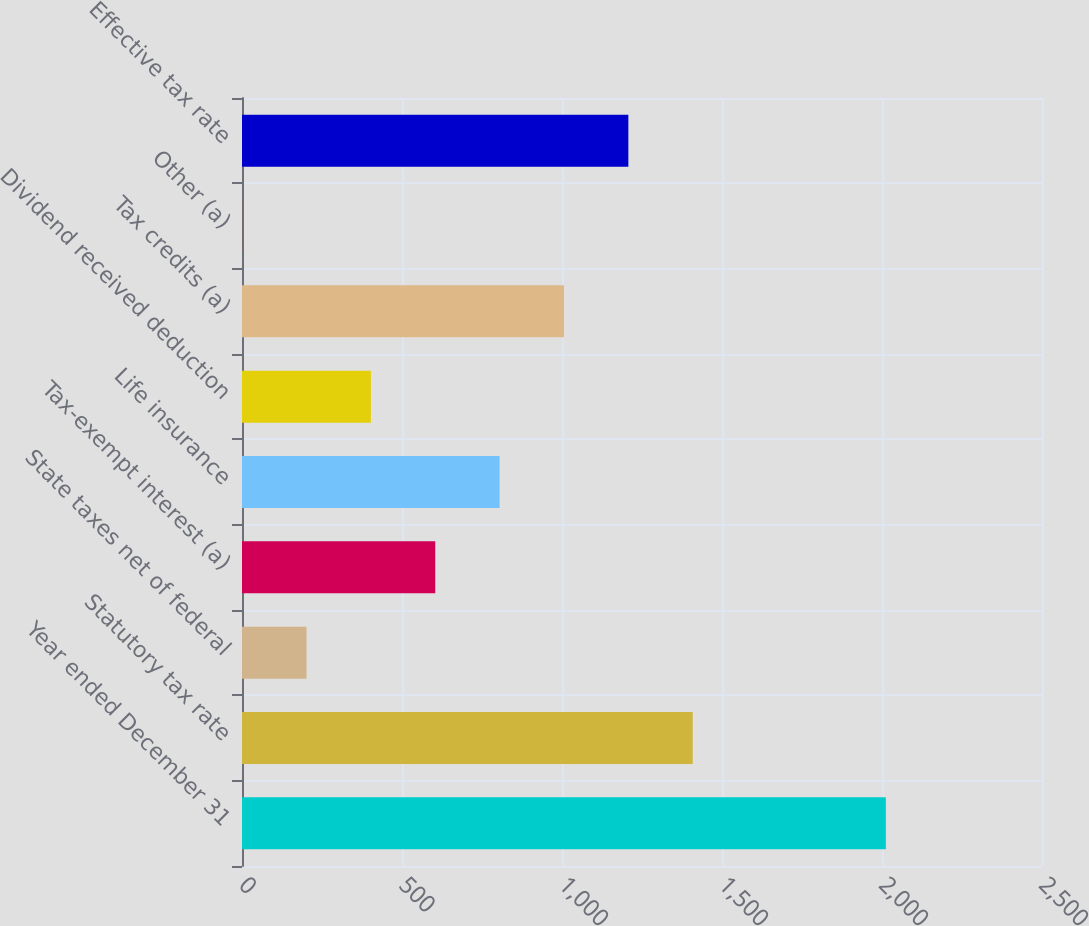<chart> <loc_0><loc_0><loc_500><loc_500><bar_chart><fcel>Year ended December 31<fcel>Statutory tax rate<fcel>State taxes net of federal<fcel>Tax-exempt interest (a)<fcel>Life insurance<fcel>Dividend received deduction<fcel>Tax credits (a)<fcel>Other (a)<fcel>Effective tax rate<nl><fcel>2012<fcel>1408.52<fcel>201.56<fcel>603.88<fcel>805.04<fcel>402.72<fcel>1006.2<fcel>0.4<fcel>1207.36<nl></chart> 